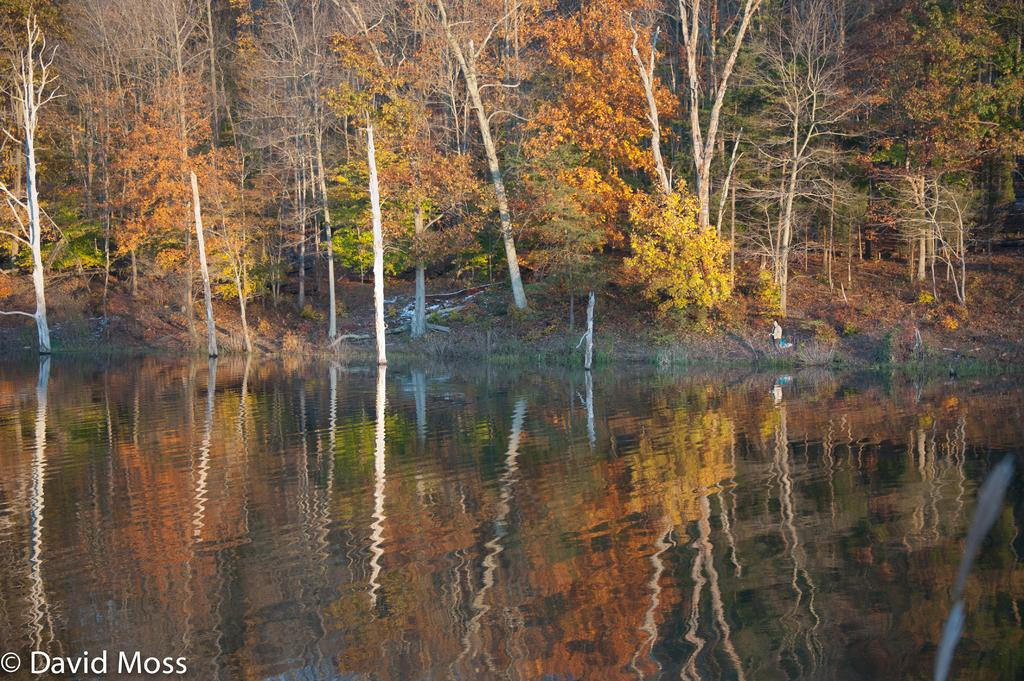What can be seen in the bottom left corner of the image? There is a watermark on the bottom left of the image. What is visible at the bottom of the image? There is water at the bottom of the image. What type of vegetation is present in the background of the image? There are trees and plants in the background of the image. Can you describe the person in the background of the image? There is a person in the background of the image, but no specific details about the person are provided. What type of ground surface is visible in the background of the image? There is grass on the ground in the background of the image. What type of smoke can be seen coming from the person's mouth in the image? There is no smoke visible in the image, nor is there any indication that a person is smoking. 